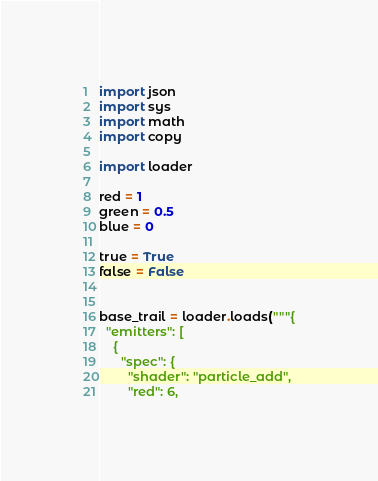Convert code to text. <code><loc_0><loc_0><loc_500><loc_500><_Python_>import json
import sys
import math
import copy

import loader

red = 1
green = 0.5
blue = 0

true = True
false = False


base_trail = loader.loads("""{
  "emitters": [
    {
      "spec": {
        "shader": "particle_add",
        "red": 6,</code> 